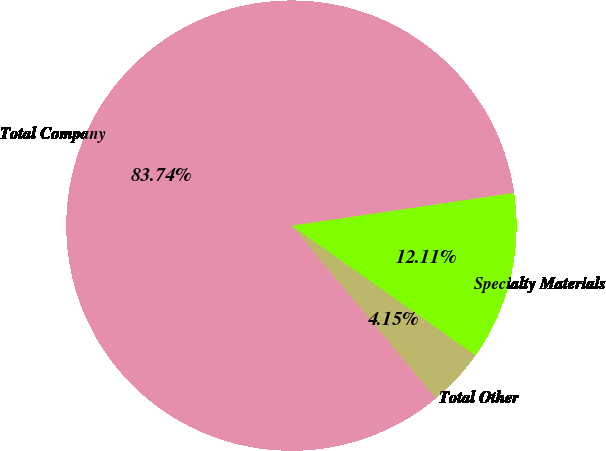Convert chart. <chart><loc_0><loc_0><loc_500><loc_500><pie_chart><fcel>Specialty Materials<fcel>Total Other<fcel>Total Company<nl><fcel>12.11%<fcel>4.15%<fcel>83.75%<nl></chart> 